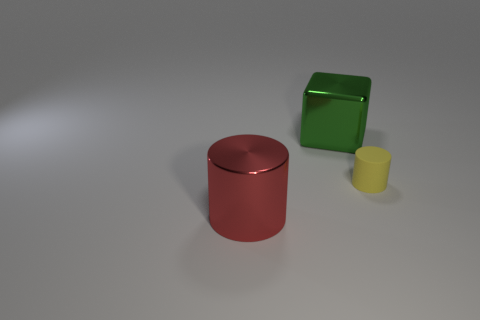Add 2 tiny cylinders. How many objects exist? 5 Subtract all blocks. How many objects are left? 2 Subtract all small matte cylinders. Subtract all green objects. How many objects are left? 1 Add 2 cubes. How many cubes are left? 3 Add 2 large brown spheres. How many large brown spheres exist? 2 Subtract 0 brown blocks. How many objects are left? 3 